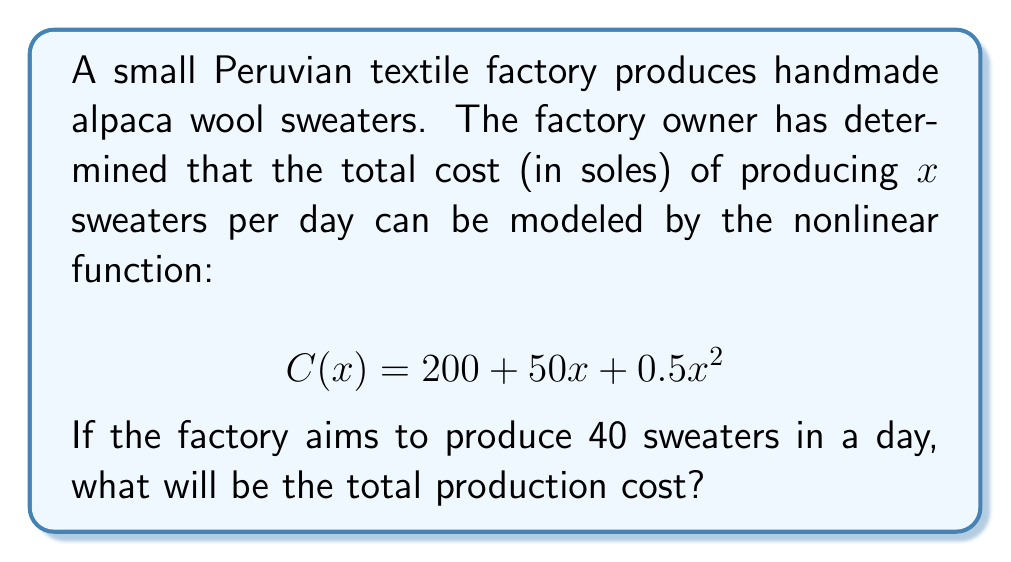Can you solve this math problem? To solve this problem, we need to follow these steps:

1. Identify the given information:
   - The cost function is $C(x) = 200 + 50x + 0.5x^2$
   - We want to find the cost for $x = 40$ sweaters

2. Substitute $x = 40$ into the cost function:
   $$C(40) = 200 + 50(40) + 0.5(40)^2$$

3. Simplify the expression:
   $$C(40) = 200 + 2000 + 0.5(1600)$$
   $$C(40) = 200 + 2000 + 800$$

4. Calculate the final result:
   $$C(40) = 3000$$

Therefore, the total production cost for 40 sweaters in a day will be 3000 soles.
Answer: 3000 soles 